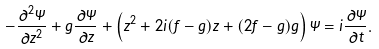<formula> <loc_0><loc_0><loc_500><loc_500>- \frac { \partial ^ { 2 } \Psi } { \partial z ^ { 2 } } + \dot { g } \frac { \partial \Psi } { \partial z } + \left ( z ^ { 2 } + 2 i ( f - g ) z + ( 2 f - g ) g \right ) \Psi = i \frac { \partial \Psi } { \partial t } .</formula> 